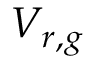Convert formula to latex. <formula><loc_0><loc_0><loc_500><loc_500>V _ { r , g }</formula> 